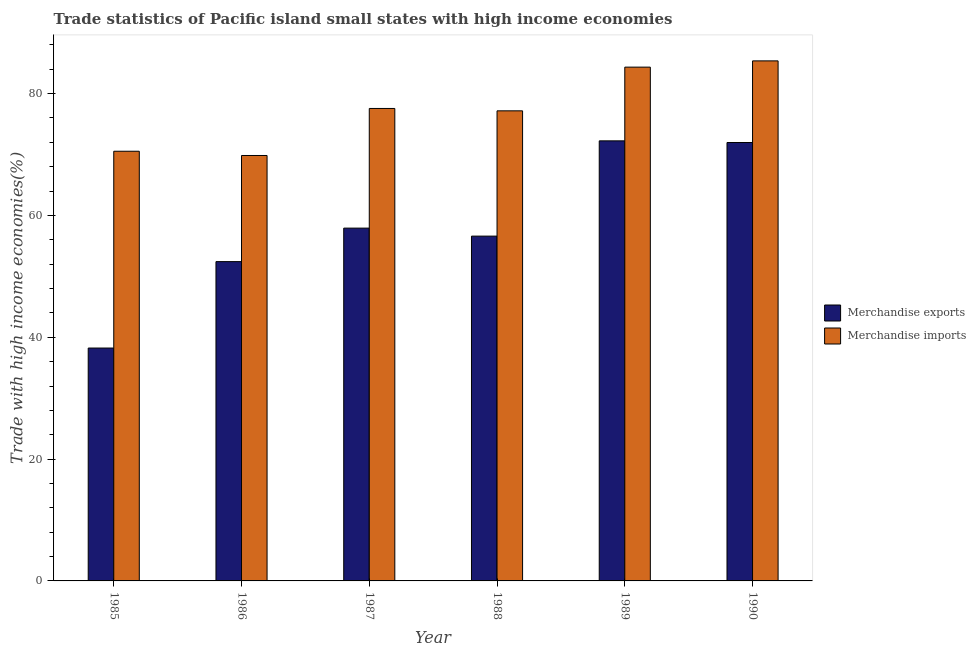How many different coloured bars are there?
Make the answer very short. 2. How many bars are there on the 6th tick from the left?
Your answer should be very brief. 2. How many bars are there on the 5th tick from the right?
Your answer should be very brief. 2. What is the label of the 6th group of bars from the left?
Ensure brevity in your answer.  1990. What is the merchandise exports in 1986?
Ensure brevity in your answer.  52.42. Across all years, what is the maximum merchandise exports?
Your response must be concise. 72.25. Across all years, what is the minimum merchandise exports?
Your answer should be compact. 38.23. In which year was the merchandise exports maximum?
Give a very brief answer. 1989. What is the total merchandise exports in the graph?
Give a very brief answer. 349.4. What is the difference between the merchandise imports in 1986 and that in 1990?
Your response must be concise. -15.53. What is the difference between the merchandise exports in 1986 and the merchandise imports in 1990?
Provide a short and direct response. -19.55. What is the average merchandise exports per year?
Offer a terse response. 58.23. In how many years, is the merchandise imports greater than 40 %?
Your answer should be compact. 6. What is the ratio of the merchandise exports in 1989 to that in 1990?
Provide a short and direct response. 1. Is the merchandise exports in 1988 less than that in 1989?
Keep it short and to the point. Yes. What is the difference between the highest and the second highest merchandise imports?
Offer a very short reply. 1.03. What is the difference between the highest and the lowest merchandise imports?
Make the answer very short. 15.53. In how many years, is the merchandise exports greater than the average merchandise exports taken over all years?
Give a very brief answer. 2. What does the 2nd bar from the right in 1986 represents?
Offer a terse response. Merchandise exports. How many years are there in the graph?
Provide a short and direct response. 6. Are the values on the major ticks of Y-axis written in scientific E-notation?
Ensure brevity in your answer.  No. Does the graph contain grids?
Your response must be concise. No. Where does the legend appear in the graph?
Your answer should be compact. Center right. What is the title of the graph?
Provide a succinct answer. Trade statistics of Pacific island small states with high income economies. What is the label or title of the X-axis?
Offer a terse response. Year. What is the label or title of the Y-axis?
Offer a very short reply. Trade with high income economies(%). What is the Trade with high income economies(%) of Merchandise exports in 1985?
Make the answer very short. 38.23. What is the Trade with high income economies(%) of Merchandise imports in 1985?
Your answer should be very brief. 70.54. What is the Trade with high income economies(%) in Merchandise exports in 1986?
Your response must be concise. 52.42. What is the Trade with high income economies(%) of Merchandise imports in 1986?
Offer a terse response. 69.84. What is the Trade with high income economies(%) in Merchandise exports in 1987?
Ensure brevity in your answer.  57.92. What is the Trade with high income economies(%) in Merchandise imports in 1987?
Offer a very short reply. 77.56. What is the Trade with high income economies(%) of Merchandise exports in 1988?
Keep it short and to the point. 56.61. What is the Trade with high income economies(%) in Merchandise imports in 1988?
Your answer should be compact. 77.17. What is the Trade with high income economies(%) in Merchandise exports in 1989?
Provide a succinct answer. 72.25. What is the Trade with high income economies(%) in Merchandise imports in 1989?
Ensure brevity in your answer.  84.35. What is the Trade with high income economies(%) in Merchandise exports in 1990?
Your response must be concise. 71.97. What is the Trade with high income economies(%) in Merchandise imports in 1990?
Offer a terse response. 85.38. Across all years, what is the maximum Trade with high income economies(%) in Merchandise exports?
Offer a very short reply. 72.25. Across all years, what is the maximum Trade with high income economies(%) of Merchandise imports?
Make the answer very short. 85.38. Across all years, what is the minimum Trade with high income economies(%) of Merchandise exports?
Your answer should be very brief. 38.23. Across all years, what is the minimum Trade with high income economies(%) of Merchandise imports?
Offer a very short reply. 69.84. What is the total Trade with high income economies(%) in Merchandise exports in the graph?
Offer a terse response. 349.4. What is the total Trade with high income economies(%) of Merchandise imports in the graph?
Your answer should be very brief. 464.84. What is the difference between the Trade with high income economies(%) in Merchandise exports in 1985 and that in 1986?
Your answer should be very brief. -14.19. What is the difference between the Trade with high income economies(%) of Merchandise imports in 1985 and that in 1986?
Offer a very short reply. 0.7. What is the difference between the Trade with high income economies(%) of Merchandise exports in 1985 and that in 1987?
Provide a succinct answer. -19.69. What is the difference between the Trade with high income economies(%) in Merchandise imports in 1985 and that in 1987?
Your answer should be very brief. -7.02. What is the difference between the Trade with high income economies(%) of Merchandise exports in 1985 and that in 1988?
Keep it short and to the point. -18.37. What is the difference between the Trade with high income economies(%) of Merchandise imports in 1985 and that in 1988?
Your response must be concise. -6.63. What is the difference between the Trade with high income economies(%) in Merchandise exports in 1985 and that in 1989?
Give a very brief answer. -34.01. What is the difference between the Trade with high income economies(%) of Merchandise imports in 1985 and that in 1989?
Offer a very short reply. -13.81. What is the difference between the Trade with high income economies(%) in Merchandise exports in 1985 and that in 1990?
Ensure brevity in your answer.  -33.74. What is the difference between the Trade with high income economies(%) in Merchandise imports in 1985 and that in 1990?
Give a very brief answer. -14.83. What is the difference between the Trade with high income economies(%) of Merchandise exports in 1986 and that in 1987?
Your answer should be very brief. -5.5. What is the difference between the Trade with high income economies(%) of Merchandise imports in 1986 and that in 1987?
Provide a succinct answer. -7.72. What is the difference between the Trade with high income economies(%) of Merchandise exports in 1986 and that in 1988?
Offer a terse response. -4.19. What is the difference between the Trade with high income economies(%) in Merchandise imports in 1986 and that in 1988?
Make the answer very short. -7.33. What is the difference between the Trade with high income economies(%) of Merchandise exports in 1986 and that in 1989?
Your answer should be very brief. -19.83. What is the difference between the Trade with high income economies(%) in Merchandise imports in 1986 and that in 1989?
Provide a succinct answer. -14.51. What is the difference between the Trade with high income economies(%) in Merchandise exports in 1986 and that in 1990?
Offer a terse response. -19.55. What is the difference between the Trade with high income economies(%) in Merchandise imports in 1986 and that in 1990?
Keep it short and to the point. -15.53. What is the difference between the Trade with high income economies(%) of Merchandise exports in 1987 and that in 1988?
Keep it short and to the point. 1.31. What is the difference between the Trade with high income economies(%) in Merchandise imports in 1987 and that in 1988?
Ensure brevity in your answer.  0.39. What is the difference between the Trade with high income economies(%) of Merchandise exports in 1987 and that in 1989?
Give a very brief answer. -14.33. What is the difference between the Trade with high income economies(%) in Merchandise imports in 1987 and that in 1989?
Make the answer very short. -6.78. What is the difference between the Trade with high income economies(%) in Merchandise exports in 1987 and that in 1990?
Make the answer very short. -14.06. What is the difference between the Trade with high income economies(%) of Merchandise imports in 1987 and that in 1990?
Offer a terse response. -7.81. What is the difference between the Trade with high income economies(%) of Merchandise exports in 1988 and that in 1989?
Give a very brief answer. -15.64. What is the difference between the Trade with high income economies(%) in Merchandise imports in 1988 and that in 1989?
Your response must be concise. -7.17. What is the difference between the Trade with high income economies(%) of Merchandise exports in 1988 and that in 1990?
Your response must be concise. -15.37. What is the difference between the Trade with high income economies(%) in Merchandise imports in 1988 and that in 1990?
Your response must be concise. -8.2. What is the difference between the Trade with high income economies(%) in Merchandise exports in 1989 and that in 1990?
Give a very brief answer. 0.27. What is the difference between the Trade with high income economies(%) of Merchandise imports in 1989 and that in 1990?
Offer a terse response. -1.03. What is the difference between the Trade with high income economies(%) in Merchandise exports in 1985 and the Trade with high income economies(%) in Merchandise imports in 1986?
Your answer should be very brief. -31.61. What is the difference between the Trade with high income economies(%) of Merchandise exports in 1985 and the Trade with high income economies(%) of Merchandise imports in 1987?
Provide a succinct answer. -39.33. What is the difference between the Trade with high income economies(%) of Merchandise exports in 1985 and the Trade with high income economies(%) of Merchandise imports in 1988?
Your response must be concise. -38.94. What is the difference between the Trade with high income economies(%) of Merchandise exports in 1985 and the Trade with high income economies(%) of Merchandise imports in 1989?
Make the answer very short. -46.12. What is the difference between the Trade with high income economies(%) in Merchandise exports in 1985 and the Trade with high income economies(%) in Merchandise imports in 1990?
Offer a terse response. -47.14. What is the difference between the Trade with high income economies(%) in Merchandise exports in 1986 and the Trade with high income economies(%) in Merchandise imports in 1987?
Offer a terse response. -25.14. What is the difference between the Trade with high income economies(%) in Merchandise exports in 1986 and the Trade with high income economies(%) in Merchandise imports in 1988?
Your answer should be very brief. -24.75. What is the difference between the Trade with high income economies(%) of Merchandise exports in 1986 and the Trade with high income economies(%) of Merchandise imports in 1989?
Make the answer very short. -31.93. What is the difference between the Trade with high income economies(%) of Merchandise exports in 1986 and the Trade with high income economies(%) of Merchandise imports in 1990?
Give a very brief answer. -32.96. What is the difference between the Trade with high income economies(%) of Merchandise exports in 1987 and the Trade with high income economies(%) of Merchandise imports in 1988?
Make the answer very short. -19.26. What is the difference between the Trade with high income economies(%) of Merchandise exports in 1987 and the Trade with high income economies(%) of Merchandise imports in 1989?
Offer a very short reply. -26.43. What is the difference between the Trade with high income economies(%) in Merchandise exports in 1987 and the Trade with high income economies(%) in Merchandise imports in 1990?
Offer a very short reply. -27.46. What is the difference between the Trade with high income economies(%) in Merchandise exports in 1988 and the Trade with high income economies(%) in Merchandise imports in 1989?
Offer a terse response. -27.74. What is the difference between the Trade with high income economies(%) of Merchandise exports in 1988 and the Trade with high income economies(%) of Merchandise imports in 1990?
Offer a terse response. -28.77. What is the difference between the Trade with high income economies(%) in Merchandise exports in 1989 and the Trade with high income economies(%) in Merchandise imports in 1990?
Keep it short and to the point. -13.13. What is the average Trade with high income economies(%) in Merchandise exports per year?
Provide a succinct answer. 58.23. What is the average Trade with high income economies(%) in Merchandise imports per year?
Your answer should be very brief. 77.47. In the year 1985, what is the difference between the Trade with high income economies(%) of Merchandise exports and Trade with high income economies(%) of Merchandise imports?
Make the answer very short. -32.31. In the year 1986, what is the difference between the Trade with high income economies(%) in Merchandise exports and Trade with high income economies(%) in Merchandise imports?
Your answer should be very brief. -17.42. In the year 1987, what is the difference between the Trade with high income economies(%) of Merchandise exports and Trade with high income economies(%) of Merchandise imports?
Provide a short and direct response. -19.64. In the year 1988, what is the difference between the Trade with high income economies(%) of Merchandise exports and Trade with high income economies(%) of Merchandise imports?
Your response must be concise. -20.57. In the year 1989, what is the difference between the Trade with high income economies(%) of Merchandise exports and Trade with high income economies(%) of Merchandise imports?
Ensure brevity in your answer.  -12.1. In the year 1990, what is the difference between the Trade with high income economies(%) of Merchandise exports and Trade with high income economies(%) of Merchandise imports?
Make the answer very short. -13.4. What is the ratio of the Trade with high income economies(%) in Merchandise exports in 1985 to that in 1986?
Ensure brevity in your answer.  0.73. What is the ratio of the Trade with high income economies(%) in Merchandise imports in 1985 to that in 1986?
Provide a succinct answer. 1.01. What is the ratio of the Trade with high income economies(%) of Merchandise exports in 1985 to that in 1987?
Your response must be concise. 0.66. What is the ratio of the Trade with high income economies(%) in Merchandise imports in 1985 to that in 1987?
Your answer should be very brief. 0.91. What is the ratio of the Trade with high income economies(%) of Merchandise exports in 1985 to that in 1988?
Offer a terse response. 0.68. What is the ratio of the Trade with high income economies(%) in Merchandise imports in 1985 to that in 1988?
Keep it short and to the point. 0.91. What is the ratio of the Trade with high income economies(%) in Merchandise exports in 1985 to that in 1989?
Your response must be concise. 0.53. What is the ratio of the Trade with high income economies(%) in Merchandise imports in 1985 to that in 1989?
Provide a succinct answer. 0.84. What is the ratio of the Trade with high income economies(%) of Merchandise exports in 1985 to that in 1990?
Provide a short and direct response. 0.53. What is the ratio of the Trade with high income economies(%) in Merchandise imports in 1985 to that in 1990?
Ensure brevity in your answer.  0.83. What is the ratio of the Trade with high income economies(%) of Merchandise exports in 1986 to that in 1987?
Give a very brief answer. 0.91. What is the ratio of the Trade with high income economies(%) of Merchandise imports in 1986 to that in 1987?
Make the answer very short. 0.9. What is the ratio of the Trade with high income economies(%) of Merchandise exports in 1986 to that in 1988?
Your response must be concise. 0.93. What is the ratio of the Trade with high income economies(%) of Merchandise imports in 1986 to that in 1988?
Your answer should be very brief. 0.91. What is the ratio of the Trade with high income economies(%) in Merchandise exports in 1986 to that in 1989?
Ensure brevity in your answer.  0.73. What is the ratio of the Trade with high income economies(%) in Merchandise imports in 1986 to that in 1989?
Ensure brevity in your answer.  0.83. What is the ratio of the Trade with high income economies(%) in Merchandise exports in 1986 to that in 1990?
Offer a terse response. 0.73. What is the ratio of the Trade with high income economies(%) in Merchandise imports in 1986 to that in 1990?
Keep it short and to the point. 0.82. What is the ratio of the Trade with high income economies(%) of Merchandise exports in 1987 to that in 1988?
Provide a short and direct response. 1.02. What is the ratio of the Trade with high income economies(%) in Merchandise imports in 1987 to that in 1988?
Ensure brevity in your answer.  1. What is the ratio of the Trade with high income economies(%) in Merchandise exports in 1987 to that in 1989?
Provide a short and direct response. 0.8. What is the ratio of the Trade with high income economies(%) of Merchandise imports in 1987 to that in 1989?
Ensure brevity in your answer.  0.92. What is the ratio of the Trade with high income economies(%) of Merchandise exports in 1987 to that in 1990?
Provide a succinct answer. 0.8. What is the ratio of the Trade with high income economies(%) of Merchandise imports in 1987 to that in 1990?
Ensure brevity in your answer.  0.91. What is the ratio of the Trade with high income economies(%) of Merchandise exports in 1988 to that in 1989?
Provide a succinct answer. 0.78. What is the ratio of the Trade with high income economies(%) in Merchandise imports in 1988 to that in 1989?
Offer a terse response. 0.92. What is the ratio of the Trade with high income economies(%) of Merchandise exports in 1988 to that in 1990?
Provide a succinct answer. 0.79. What is the ratio of the Trade with high income economies(%) in Merchandise imports in 1988 to that in 1990?
Make the answer very short. 0.9. What is the difference between the highest and the second highest Trade with high income economies(%) of Merchandise exports?
Ensure brevity in your answer.  0.27. What is the difference between the highest and the second highest Trade with high income economies(%) of Merchandise imports?
Offer a very short reply. 1.03. What is the difference between the highest and the lowest Trade with high income economies(%) in Merchandise exports?
Offer a terse response. 34.01. What is the difference between the highest and the lowest Trade with high income economies(%) of Merchandise imports?
Your answer should be compact. 15.53. 